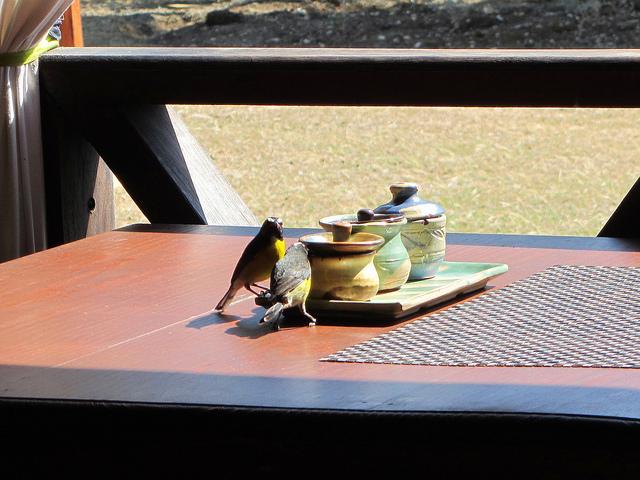Is this scene indoors or outdoors?
Give a very brief answer. Outdoors. Is it tea time?
Keep it brief. Yes. What did the two birds find to get into?
Write a very short answer. Window. 